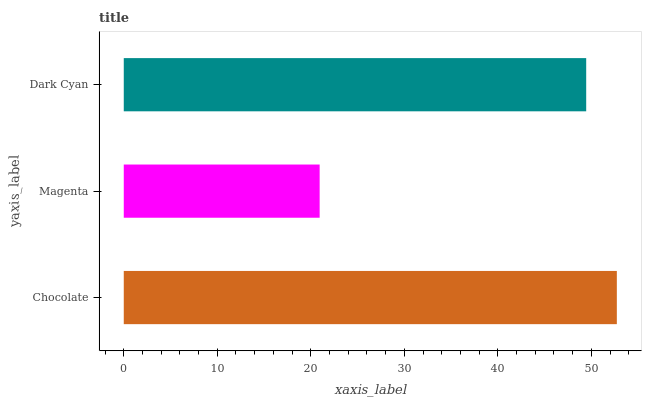Is Magenta the minimum?
Answer yes or no. Yes. Is Chocolate the maximum?
Answer yes or no. Yes. Is Dark Cyan the minimum?
Answer yes or no. No. Is Dark Cyan the maximum?
Answer yes or no. No. Is Dark Cyan greater than Magenta?
Answer yes or no. Yes. Is Magenta less than Dark Cyan?
Answer yes or no. Yes. Is Magenta greater than Dark Cyan?
Answer yes or no. No. Is Dark Cyan less than Magenta?
Answer yes or no. No. Is Dark Cyan the high median?
Answer yes or no. Yes. Is Dark Cyan the low median?
Answer yes or no. Yes. Is Chocolate the high median?
Answer yes or no. No. Is Chocolate the low median?
Answer yes or no. No. 